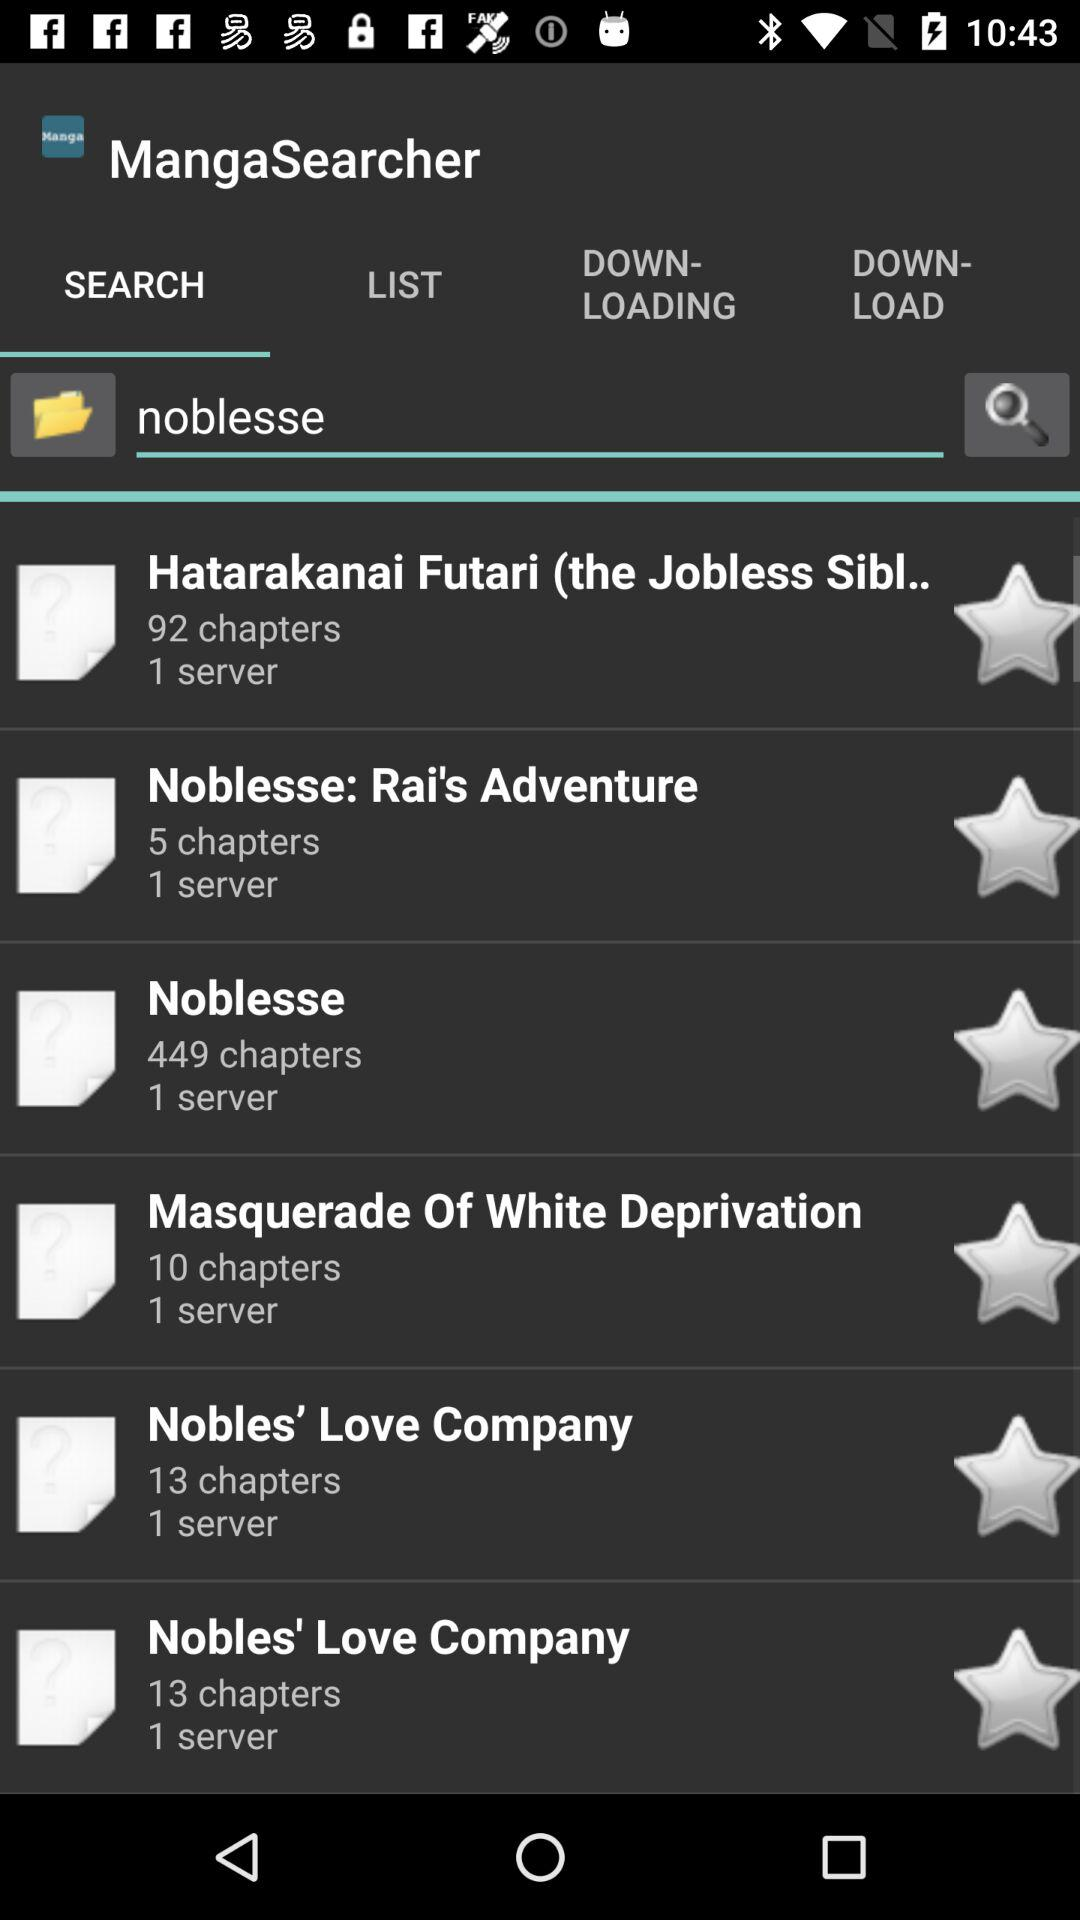How many chapters did Hatarakanai Futari have? It has 92 chapters. 